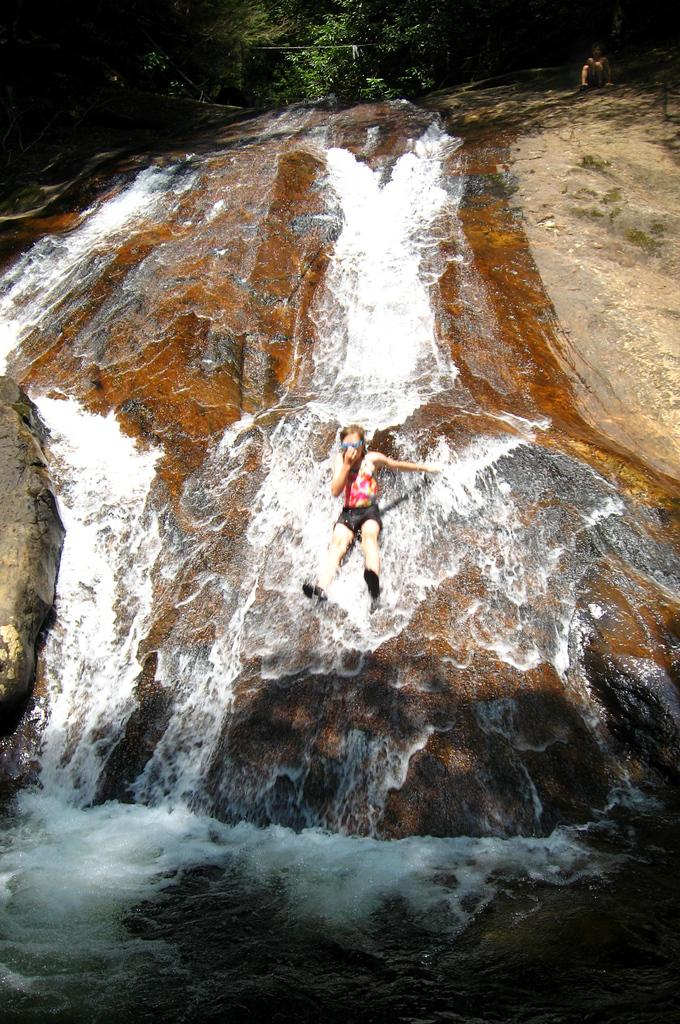What is happening in the image? There is water flowing in the image. What can be seen in the water? There is a rock in the image. Who is present in the image? A woman is seated on the rock. What is visible in the background of the image? There are trees visible in the image. Can you see any goldfish swimming in the water in the image? There are no goldfish visible in the image; it only shows water flowing and a rock with a woman seated on it. 